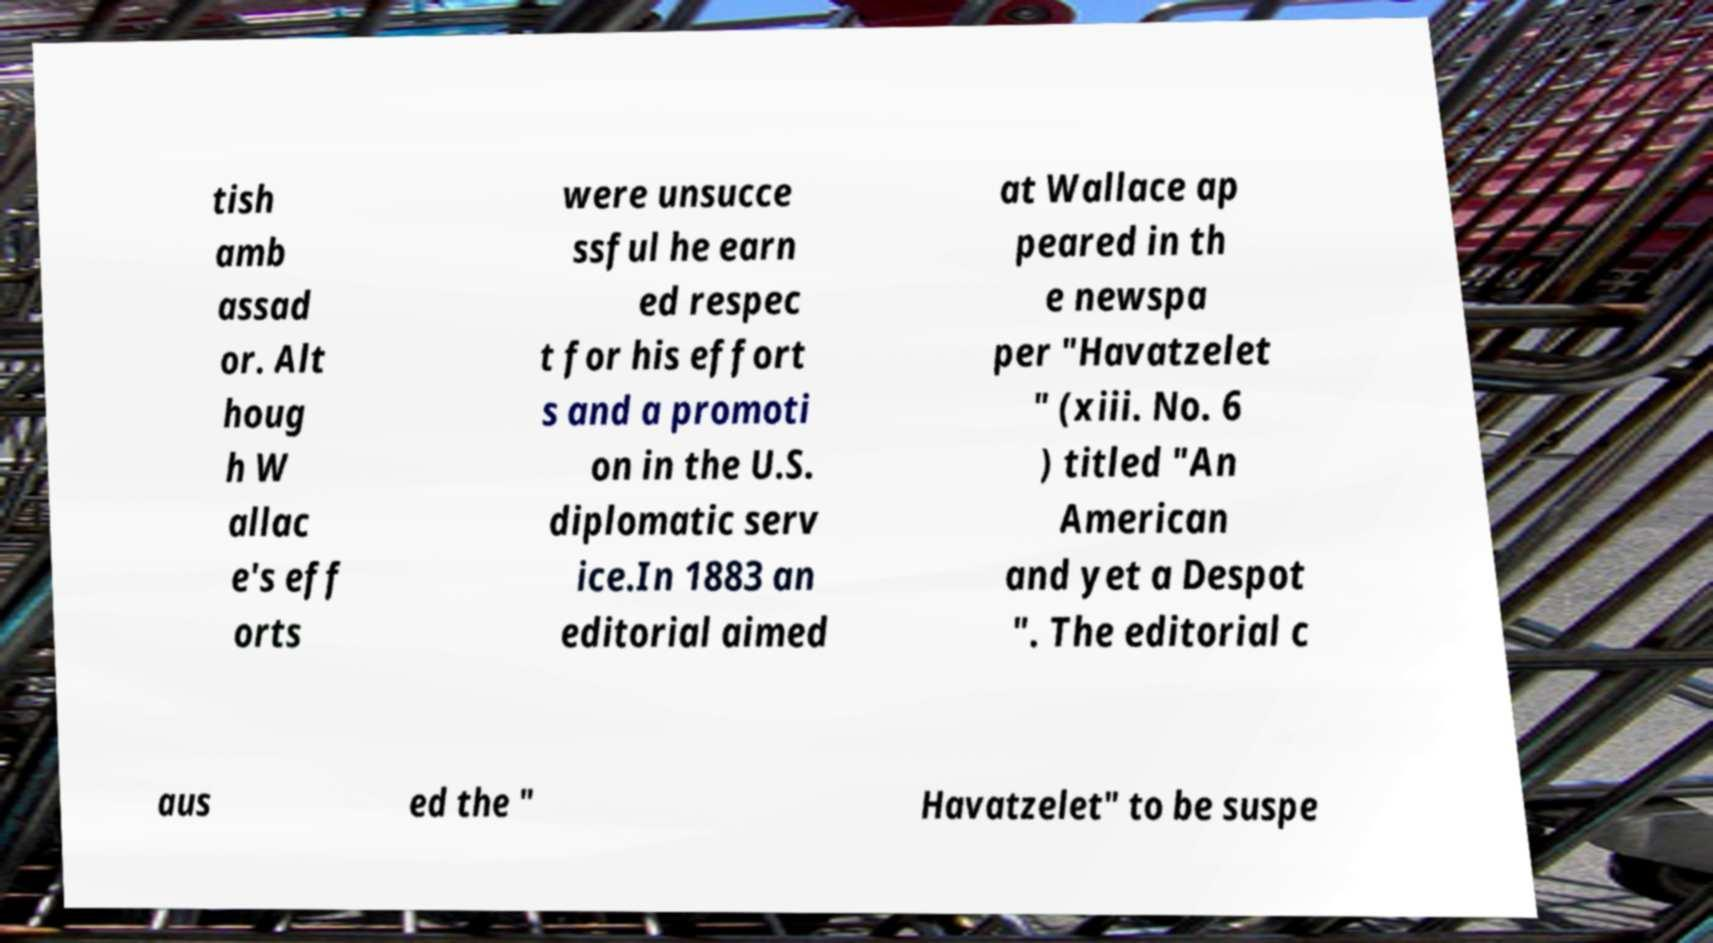Please identify and transcribe the text found in this image. tish amb assad or. Alt houg h W allac e's eff orts were unsucce ssful he earn ed respec t for his effort s and a promoti on in the U.S. diplomatic serv ice.In 1883 an editorial aimed at Wallace ap peared in th e newspa per "Havatzelet " (xiii. No. 6 ) titled "An American and yet a Despot ". The editorial c aus ed the " Havatzelet" to be suspe 